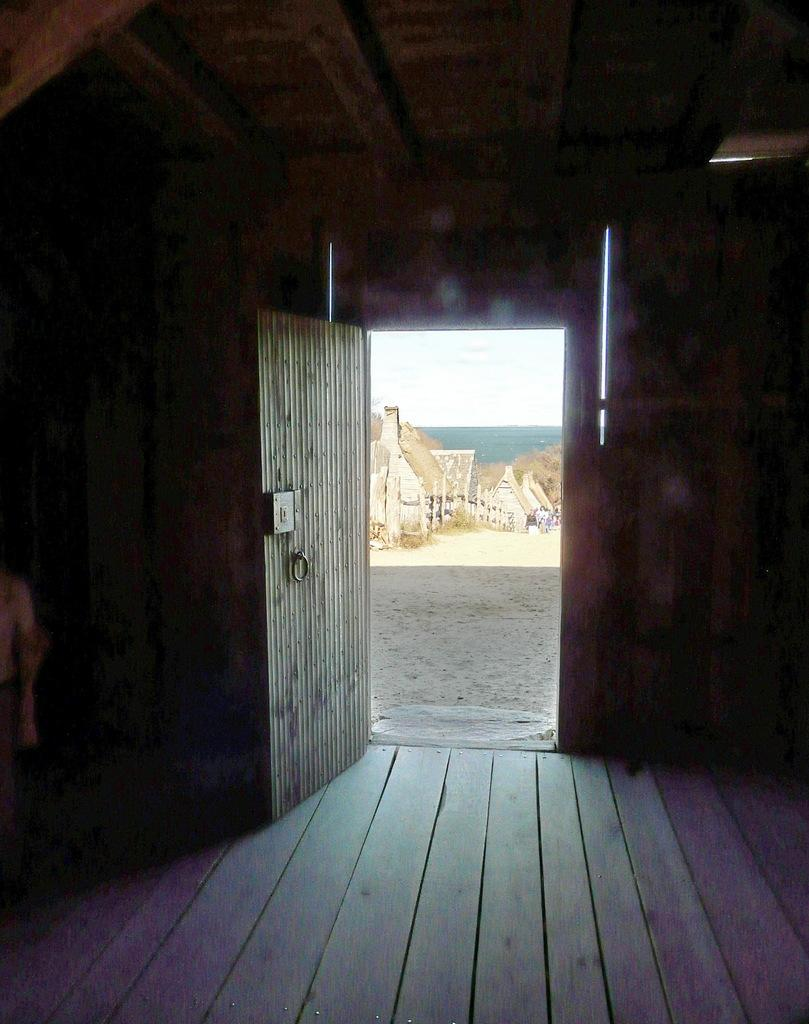What is the main architectural feature visible in the image? There is a door in the image. What material is the room constructed from? The room appears to be built with wood. What can be seen outside the door in the image? The sky is visible outside the door. What type of song can be heard playing in the background of the image? There is no indication of any music or sound in the image, so it is not possible to determine what type of song might be playing. 